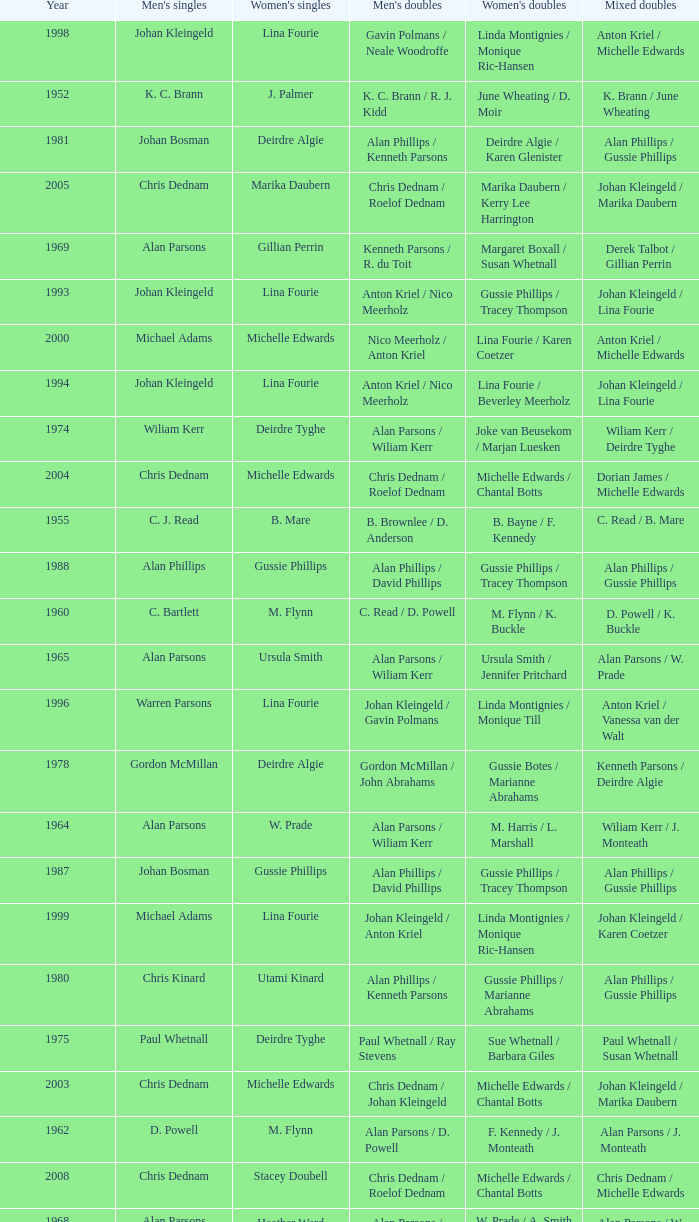Which Men's doubles have a Year smaller than 1960, and Men's singles of noel b. radford? R. C. Allen / E. S. Irwin. 